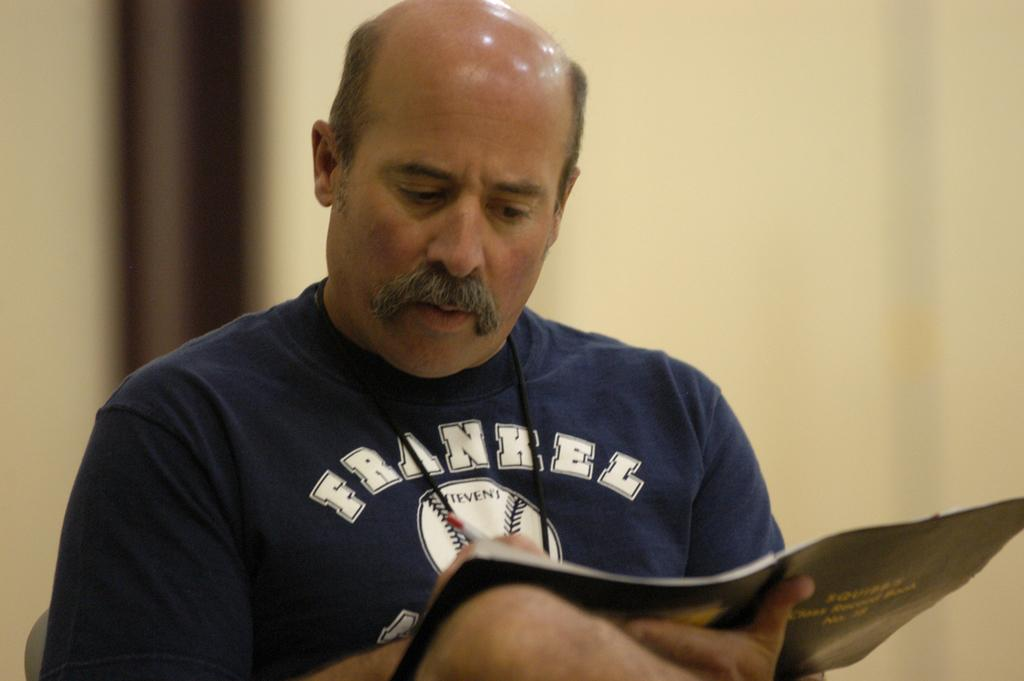<image>
Summarize the visual content of the image. A man wearing a blue Frankel baseball shirt is sitting down with a folder in his hands. 